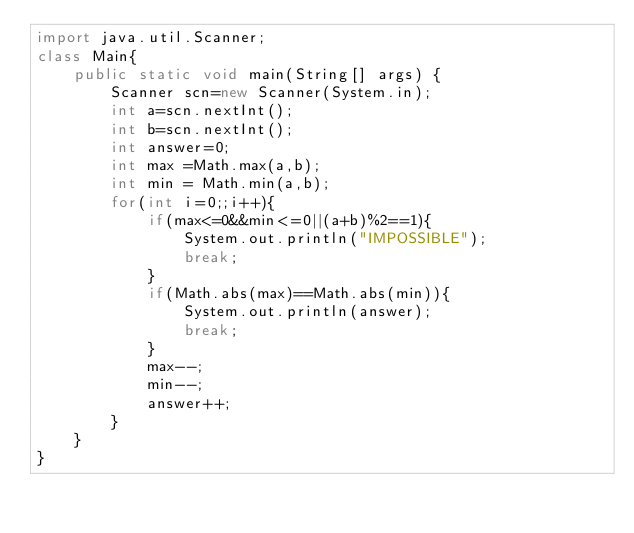<code> <loc_0><loc_0><loc_500><loc_500><_Java_>import java.util.Scanner;
class Main{
    public static void main(String[] args) {
        Scanner scn=new Scanner(System.in);
        int a=scn.nextInt();
        int b=scn.nextInt();
        int answer=0;
        int max =Math.max(a,b);
        int min = Math.min(a,b);
        for(int i=0;;i++){
            if(max<=0&&min<=0||(a+b)%2==1){
                System.out.println("IMPOSSIBLE");
                break;
            }
            if(Math.abs(max)==Math.abs(min)){
                System.out.println(answer);
                break;
            }
            max--;
            min--;
            answer++;
        }
    }
}
</code> 